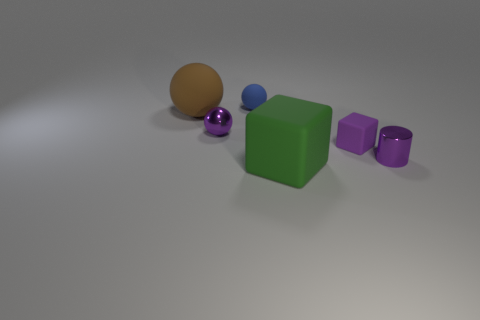What is the color of the object behind the large brown matte object?
Your answer should be very brief. Blue. There is a sphere that is the same color as the metal cylinder; what is its material?
Provide a succinct answer. Metal. How many tiny shiny objects have the same color as the large block?
Provide a short and direct response. 0. There is a blue ball; is it the same size as the ball that is in front of the big brown rubber object?
Provide a short and direct response. Yes. What is the size of the purple metal object that is behind the tiny thing on the right side of the rubber cube that is behind the purple metal cylinder?
Offer a terse response. Small. There is a large brown rubber ball; how many brown spheres are to the right of it?
Offer a very short reply. 0. What material is the small ball behind the rubber ball that is left of the tiny blue rubber object?
Provide a short and direct response. Rubber. Is there any other thing that has the same size as the purple cylinder?
Your answer should be very brief. Yes. Does the purple metallic cylinder have the same size as the green object?
Your response must be concise. No. What number of objects are either things to the left of the large block or tiny purple metallic things on the right side of the blue sphere?
Offer a terse response. 4. 